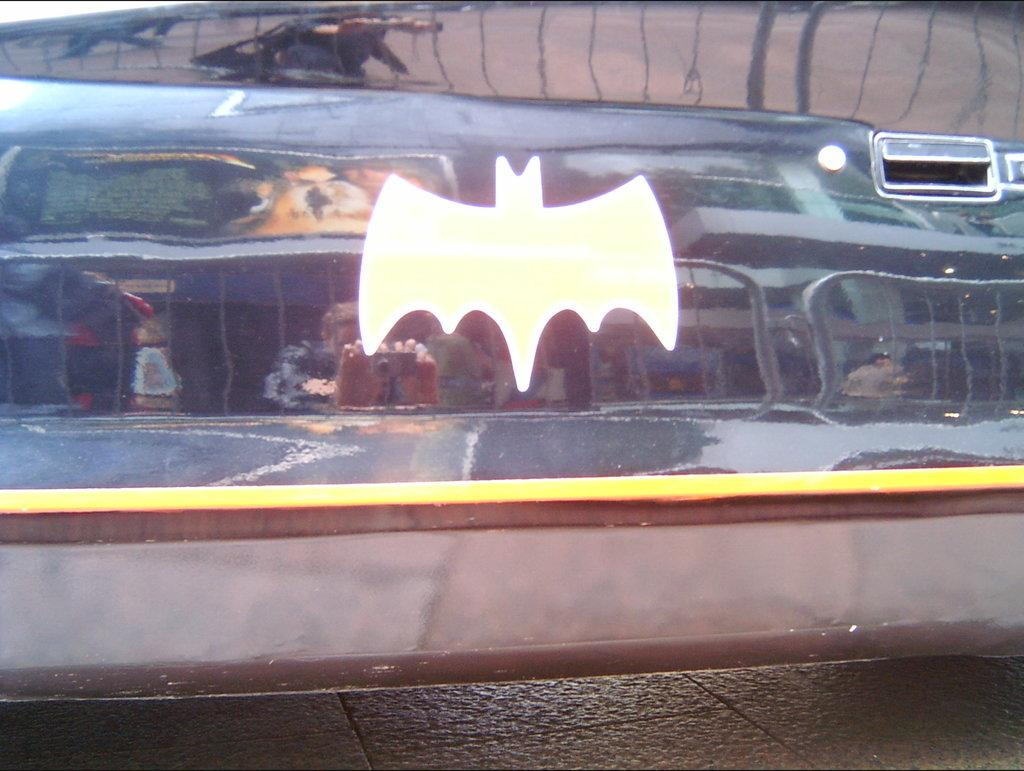What is depicted on the glass item in the image? There is a symbol of a bird on a glass item. What other feature can be seen on the glass item? There is a mirror image of some objects on the glass item. What type of paper can be seen in the image? There is no paper present in the image. What kind of flower is depicted in the mirror image on the glass item? There is no flower depicted in the mirror image on the glass item; it only shows a reflection of some objects. 